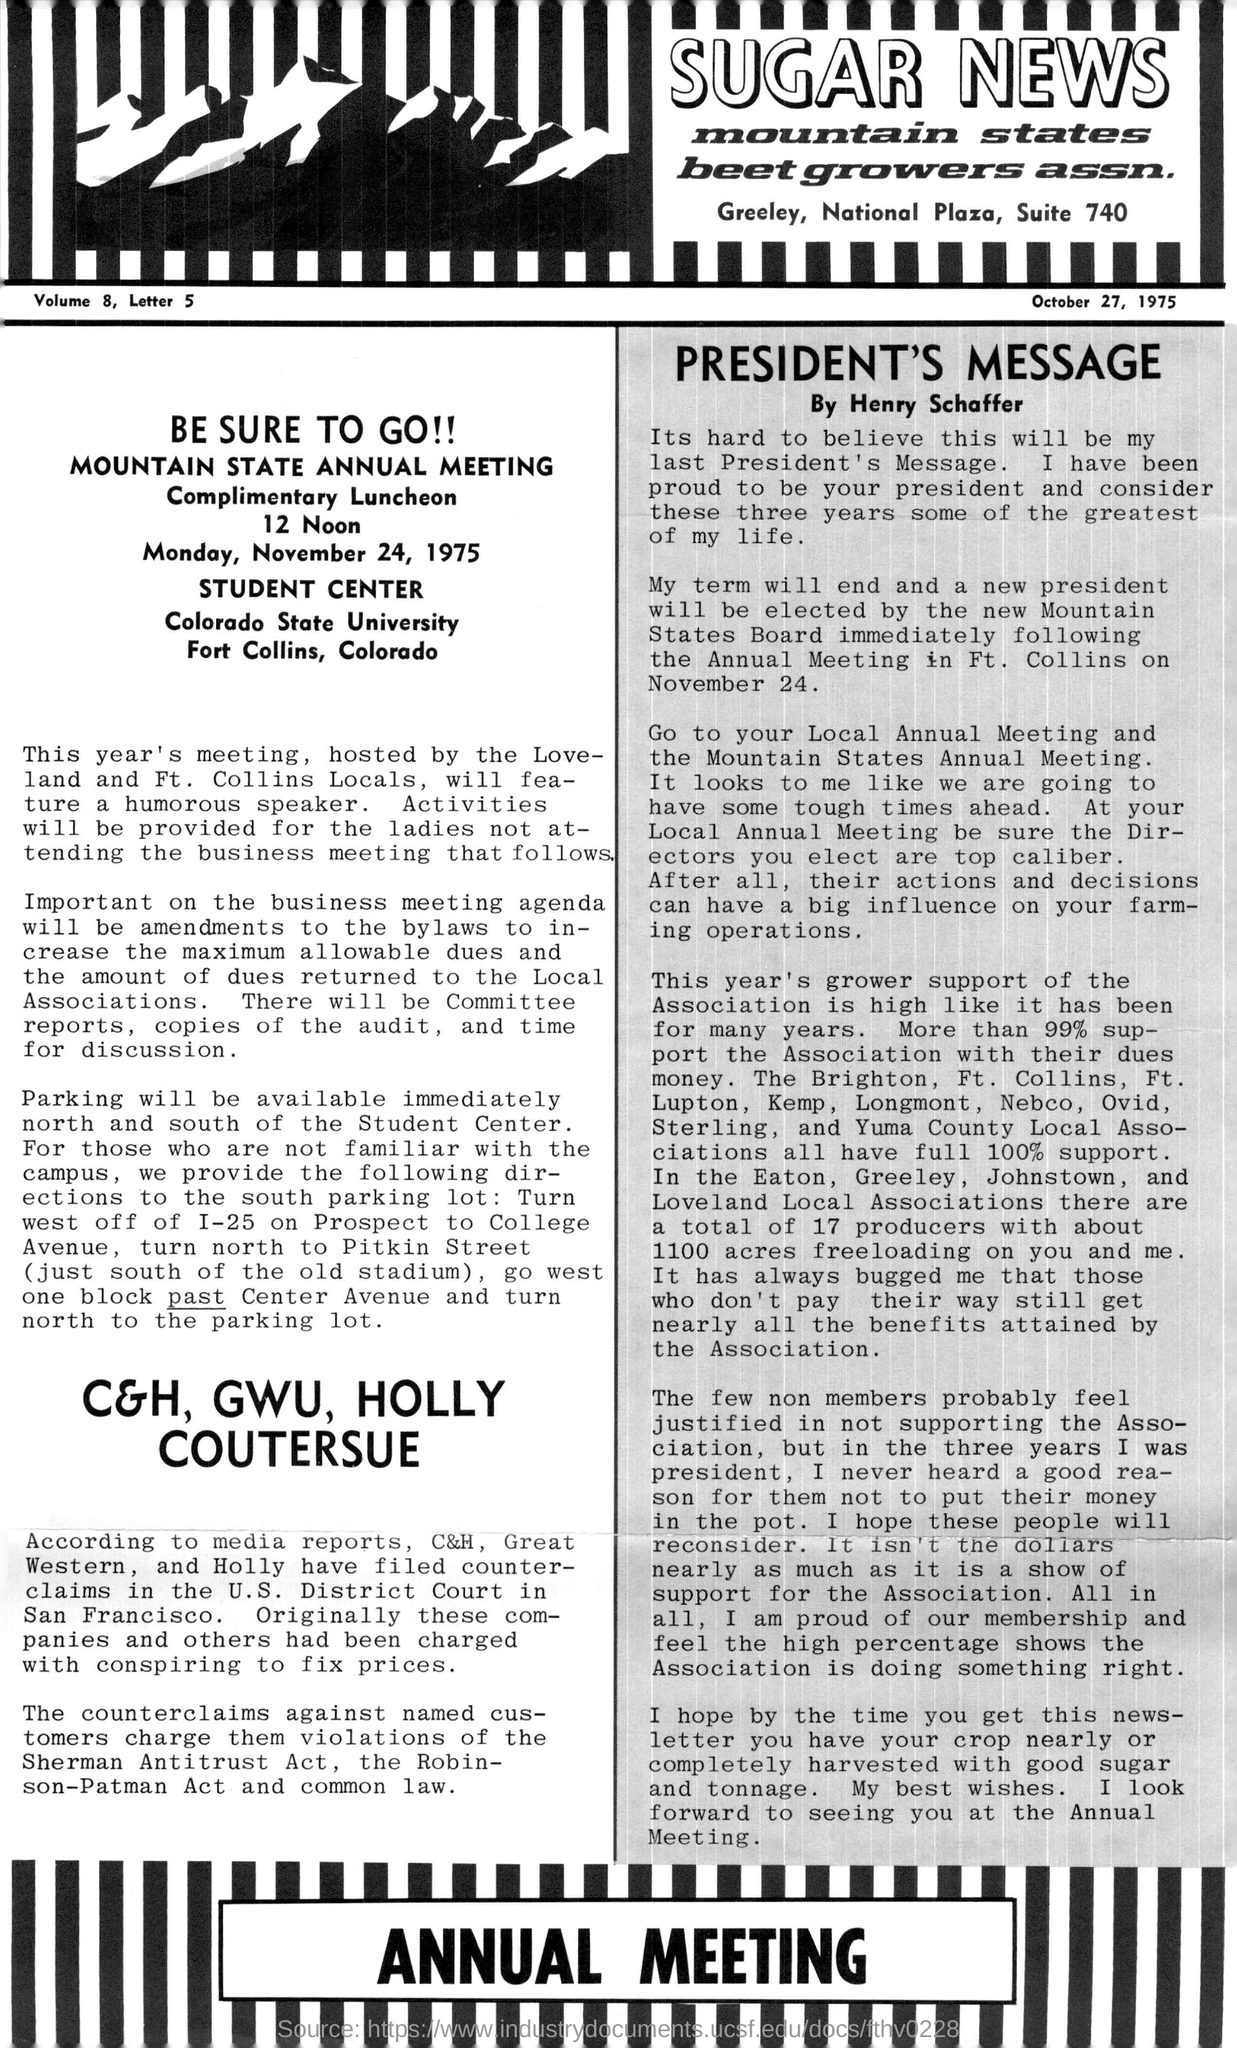Who hosted Mountain State Annual Meeting?
Provide a succinct answer. The love-land and ft. collins locals. When was the Mountain State Annual Meeting held?
Provide a succinct answer. Monday, November 24, 1975. 